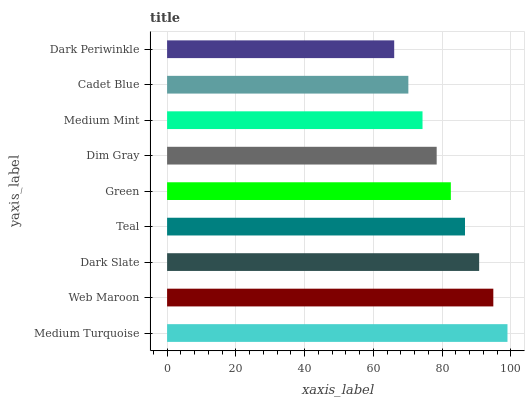Is Dark Periwinkle the minimum?
Answer yes or no. Yes. Is Medium Turquoise the maximum?
Answer yes or no. Yes. Is Web Maroon the minimum?
Answer yes or no. No. Is Web Maroon the maximum?
Answer yes or no. No. Is Medium Turquoise greater than Web Maroon?
Answer yes or no. Yes. Is Web Maroon less than Medium Turquoise?
Answer yes or no. Yes. Is Web Maroon greater than Medium Turquoise?
Answer yes or no. No. Is Medium Turquoise less than Web Maroon?
Answer yes or no. No. Is Green the high median?
Answer yes or no. Yes. Is Green the low median?
Answer yes or no. Yes. Is Medium Turquoise the high median?
Answer yes or no. No. Is Dark Periwinkle the low median?
Answer yes or no. No. 